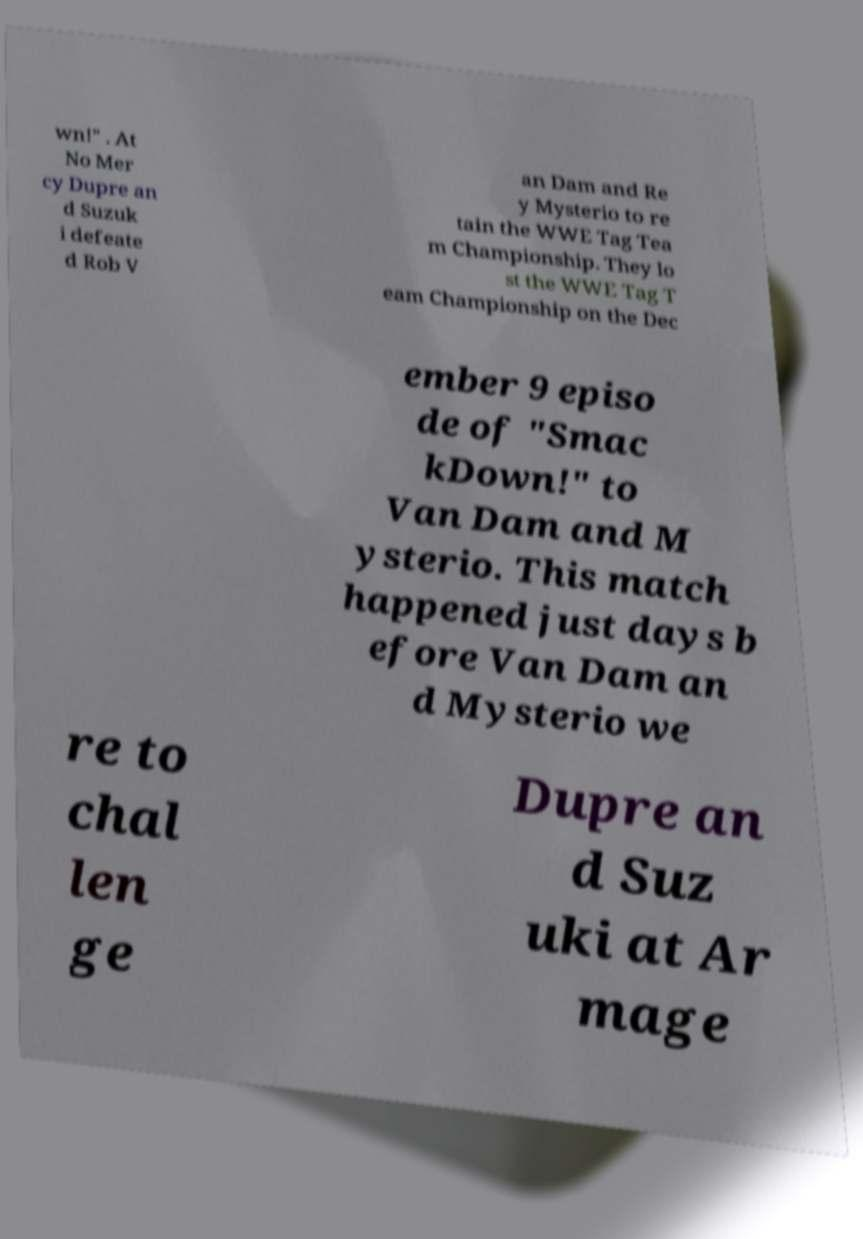Can you accurately transcribe the text from the provided image for me? wn!" . At No Mer cy Dupre an d Suzuk i defeate d Rob V an Dam and Re y Mysterio to re tain the WWE Tag Tea m Championship. They lo st the WWE Tag T eam Championship on the Dec ember 9 episo de of "Smac kDown!" to Van Dam and M ysterio. This match happened just days b efore Van Dam an d Mysterio we re to chal len ge Dupre an d Suz uki at Ar mage 